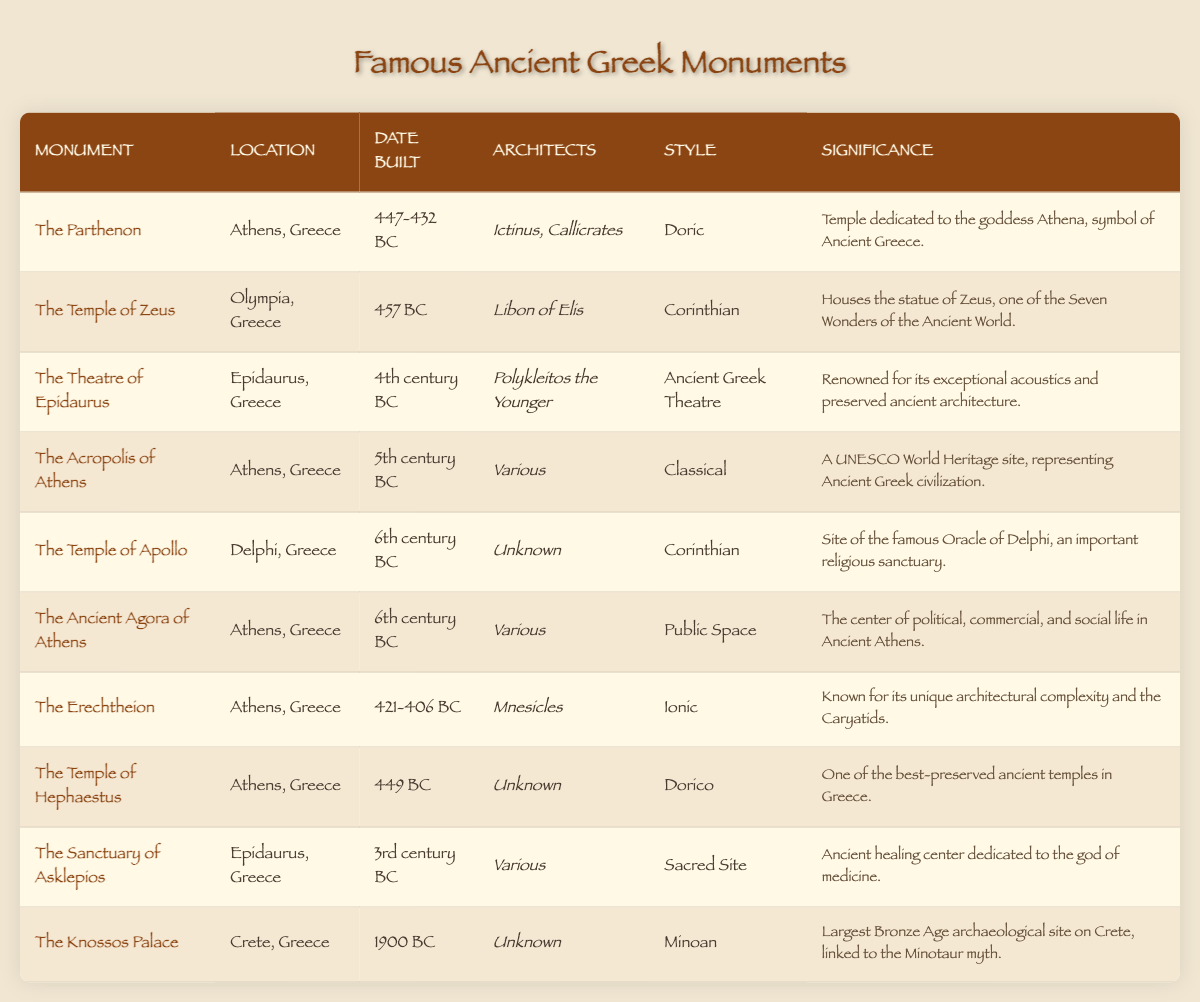What is the location of The Parthenon? The Parthenon is listed in the table under the "Location" column. Simply find the name “The Parthenon” in the "Monument" column and read across to the "Location" column. It states "Athens, Greece."
Answer: Athens, Greece Which monument is known for its exceptional acoustics? The table provides information on the notable features of different monuments. By looking through the "Significance" column, we can find that "The Theatre of Epidaurus" is noted for its exceptional acoustics.
Answer: The Theatre of Epidaurus How many ancient monuments are located in Athens? Counting the rows in the table corresponding to the "Location" column, "Athens, Greece" appears 6 times. Therefore, there are 6 ancient monuments located in Athens.
Answer: 6 Is The Temple of Hephaestus one of the best-preserved ancient temples in Greece? Checking the "Significance" column for "The Temple of Hephaestus," it states it is "one of the best-preserved ancient temples in Greece," confirming the fact is true.
Answer: Yes Which monument was built in the 6th century BC and has an unknown architect? By filtering through the "Date Built" column for "6th century BC" and checking the "Architects" column, we find "The Temple of Apollo," which lists "Unknown" as its architect.
Answer: The Temple of Apollo What architectural style is used for The Erechtheion? The architectural style of The Erechtheion can be found in the "Style" column next to its name in the "Monument" column. It states "Ionic."
Answer: Ionic Which monument is dedicated to the goddess Athena? The significance details under The Parthenon state that it is "dedicated to the goddess Athena." Thus, it directly answers the question.
Answer: The Parthenon How many monuments were built after 400 BC? We need to analyze the "Date Built" column and count all entries after 400 BC. The relevant monuments are the Temple of Apollo, The Ancient Agora of Athens, The Erechtheion, The Temple of Hephaestus, The Sanctuary of Asklepios, and The Theatre of Epidaurus, totaling 6.
Answer: 6 Which of the monuments is part of a UNESCO World Heritage site? Looking at the "Significance" column, the Acropolis of Athens is noted as a UNESCO World Heritage site, identifying it as part of this classification.
Answer: The Acropolis of Athens 